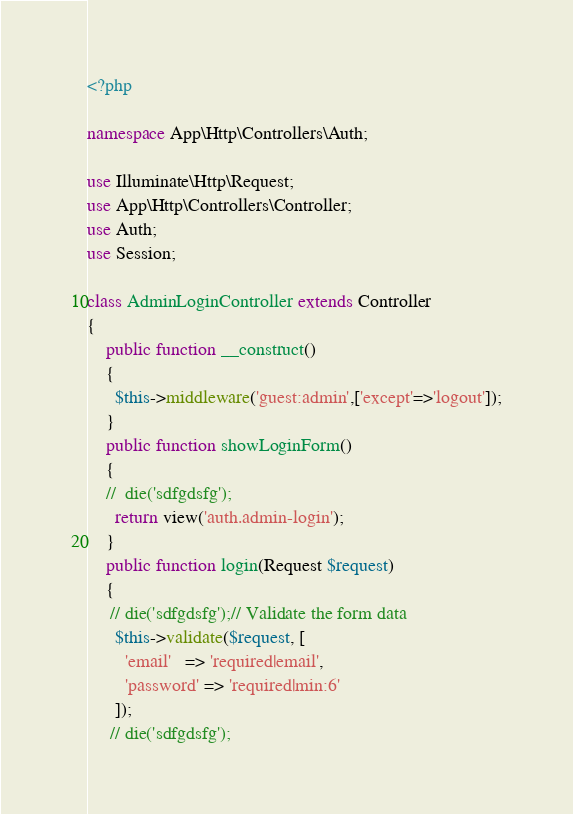Convert code to text. <code><loc_0><loc_0><loc_500><loc_500><_PHP_><?php

namespace App\Http\Controllers\Auth;

use Illuminate\Http\Request;
use App\Http\Controllers\Controller;
use Auth;
use Session;

class AdminLoginController extends Controller
{
    public function __construct()
    {
      $this->middleware('guest:admin',['except'=>'logout']);
    }
    public function showLoginForm()
    {
    //	die('sdfgdsfg');
      return view('auth.admin-login');
    }
    public function login(Request $request)
    {
     // die('sdfgdsfg');// Validate the form data
      $this->validate($request, [
        'email'   => 'required|email',
        'password' => 'required|min:6'
      ]);
     // die('sdfgdsfg');</code> 